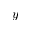<formula> <loc_0><loc_0><loc_500><loc_500>y</formula> 